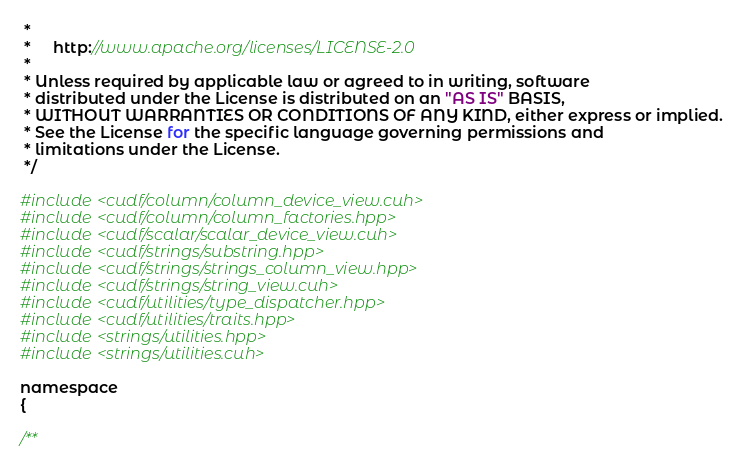<code> <loc_0><loc_0><loc_500><loc_500><_Cuda_> *
 *     http://www.apache.org/licenses/LICENSE-2.0
 *
 * Unless required by applicable law or agreed to in writing, software
 * distributed under the License is distributed on an "AS IS" BASIS,
 * WITHOUT WARRANTIES OR CONDITIONS OF ANY KIND, either express or implied.
 * See the License for the specific language governing permissions and
 * limitations under the License.
 */

#include <cudf/column/column_device_view.cuh>
#include <cudf/column/column_factories.hpp>
#include <cudf/scalar/scalar_device_view.cuh>
#include <cudf/strings/substring.hpp>
#include <cudf/strings/strings_column_view.hpp>
#include <cudf/strings/string_view.cuh>
#include <cudf/utilities/type_dispatcher.hpp>
#include <cudf/utilities/traits.hpp>
#include <strings/utilities.hpp>
#include <strings/utilities.cuh>

namespace
{

/**</code> 